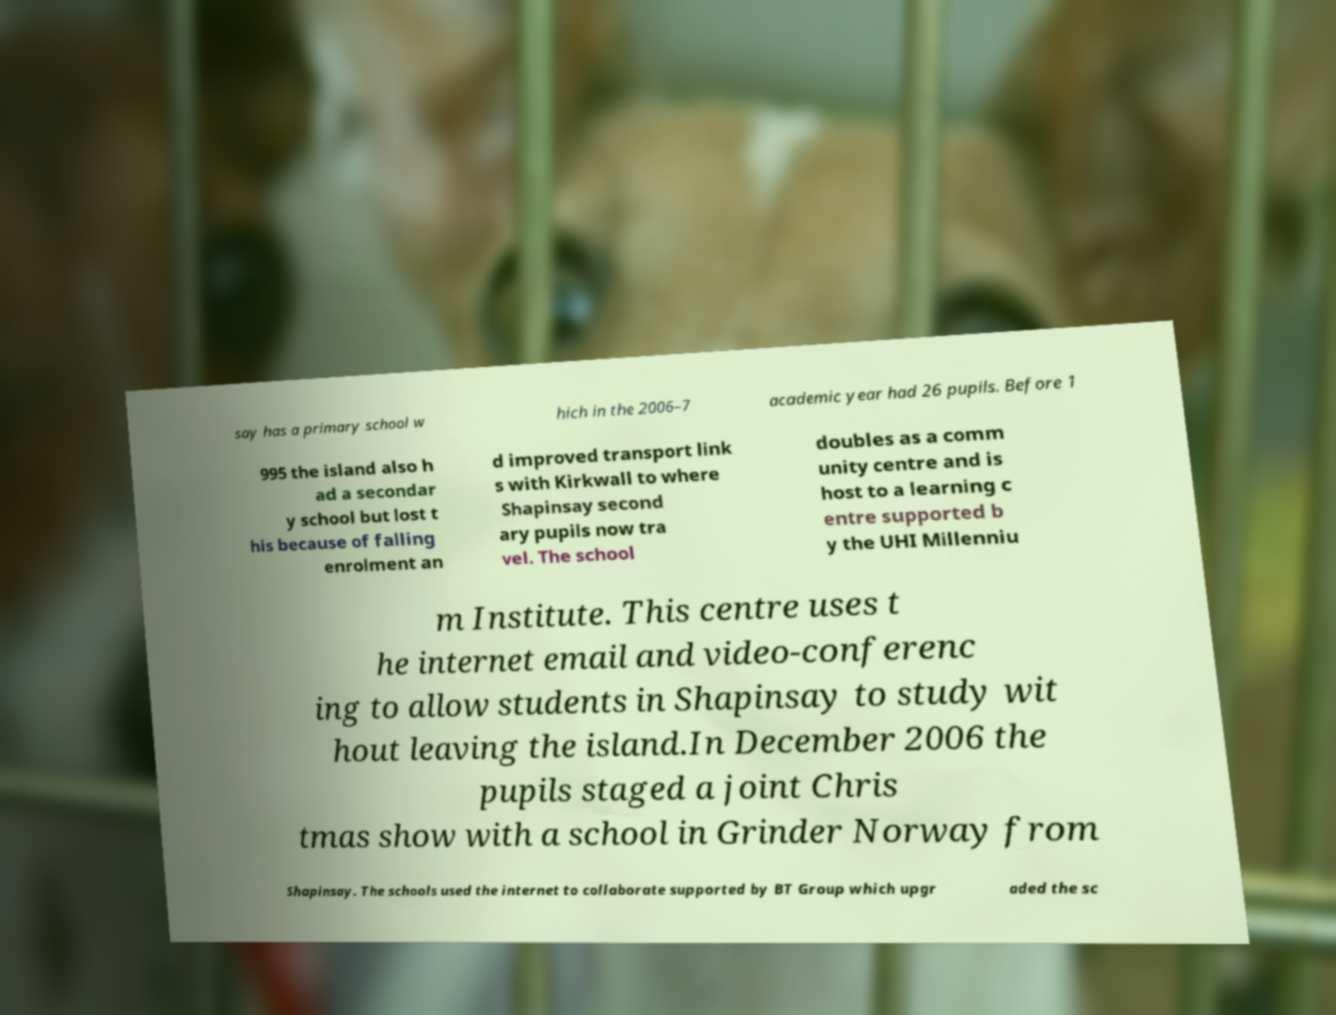For documentation purposes, I need the text within this image transcribed. Could you provide that? say has a primary school w hich in the 2006–7 academic year had 26 pupils. Before 1 995 the island also h ad a secondar y school but lost t his because of falling enrolment an d improved transport link s with Kirkwall to where Shapinsay second ary pupils now tra vel. The school doubles as a comm unity centre and is host to a learning c entre supported b y the UHI Millenniu m Institute. This centre uses t he internet email and video-conferenc ing to allow students in Shapinsay to study wit hout leaving the island.In December 2006 the pupils staged a joint Chris tmas show with a school in Grinder Norway from Shapinsay. The schools used the internet to collaborate supported by BT Group which upgr aded the sc 